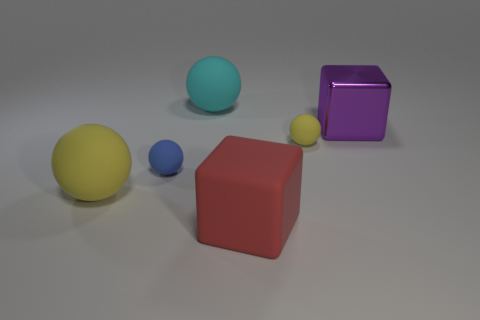Subtract all large cyan matte balls. How many balls are left? 3 Subtract 2 spheres. How many spheres are left? 2 Add 2 cyan cylinders. How many objects exist? 8 Subtract all green balls. Subtract all purple cubes. How many balls are left? 4 Subtract all cubes. How many objects are left? 4 Add 4 blue matte things. How many blue matte things are left? 5 Add 3 rubber blocks. How many rubber blocks exist? 4 Subtract 0 green spheres. How many objects are left? 6 Subtract all large shiny things. Subtract all large red things. How many objects are left? 4 